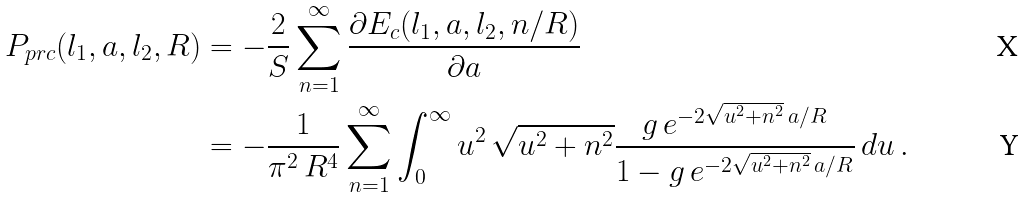<formula> <loc_0><loc_0><loc_500><loc_500>P _ { p r c } ( l _ { 1 } , a , l _ { 2 } , R ) & = - \frac { 2 } { S } \sum _ { n = 1 } ^ { \infty } \frac { \partial E _ { c } ( l _ { 1 } , a , l _ { 2 } , n / R ) } { \partial a } \\ & = - \frac { 1 } { \pi ^ { 2 } \, R ^ { 4 } } \sum _ { n = 1 } ^ { \infty } \int _ { 0 } ^ { \infty } u ^ { 2 } \, \sqrt { u ^ { 2 } + n ^ { 2 } } \frac { g \, e ^ { - 2 \sqrt { u ^ { 2 } + n ^ { 2 } } \, a / R } } { 1 - g \, e ^ { - 2 \sqrt { u ^ { 2 } + n ^ { 2 } } \, a / R } } \, d u \, .</formula> 